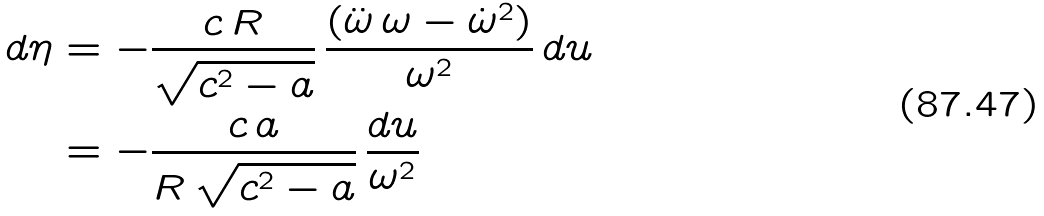Convert formula to latex. <formula><loc_0><loc_0><loc_500><loc_500>d \eta & = - \frac { c \, R } { \sqrt { c ^ { 2 } - a } } \, \frac { ( \ddot { \omega } \, \omega - \dot { \omega } ^ { 2 } ) } { \omega ^ { 2 } } \, d u \\ & = - \frac { c \, a } { R \, \sqrt { c ^ { 2 } - a } } \, \frac { d u } { \omega ^ { 2 } }</formula> 